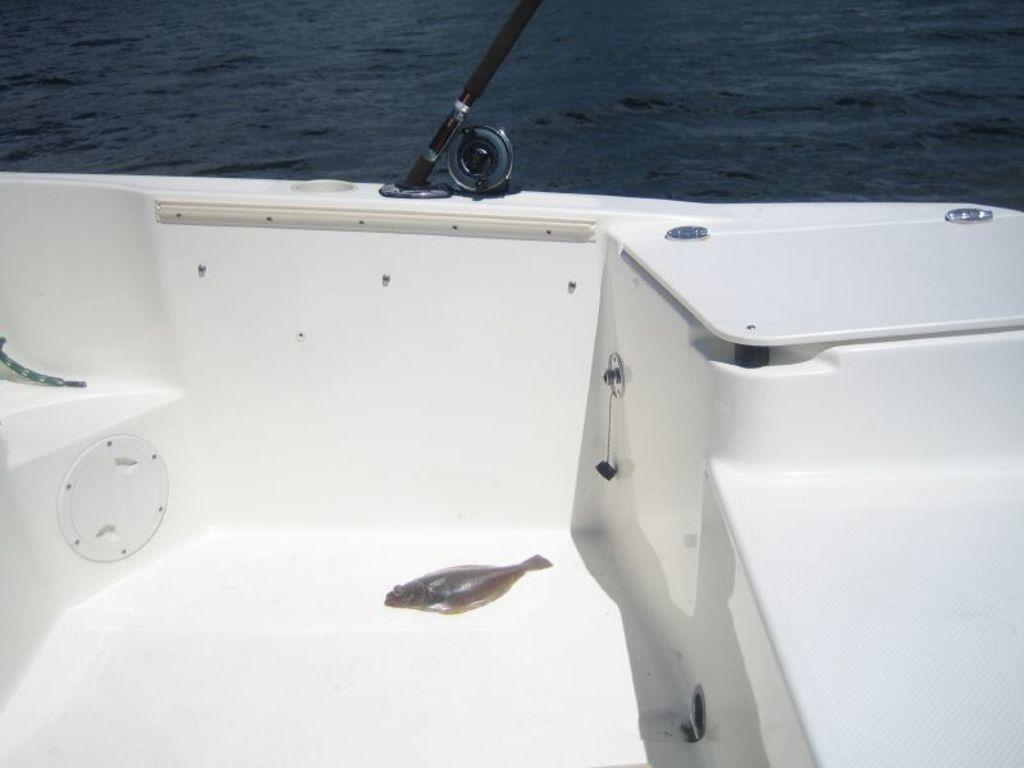What is the main subject of the image? There is a fish on a boat in the image. Where is the boat located in the image? The boat is on water in the image. What can be seen in the image that is related to fishing? There is a fishing rod in the image. What type of rose is being displayed by the laborer in the image? There is no rose or laborer present in the image. What show is being performed on the boat in the image? There is no show or performance taking place on the boat in the image. 